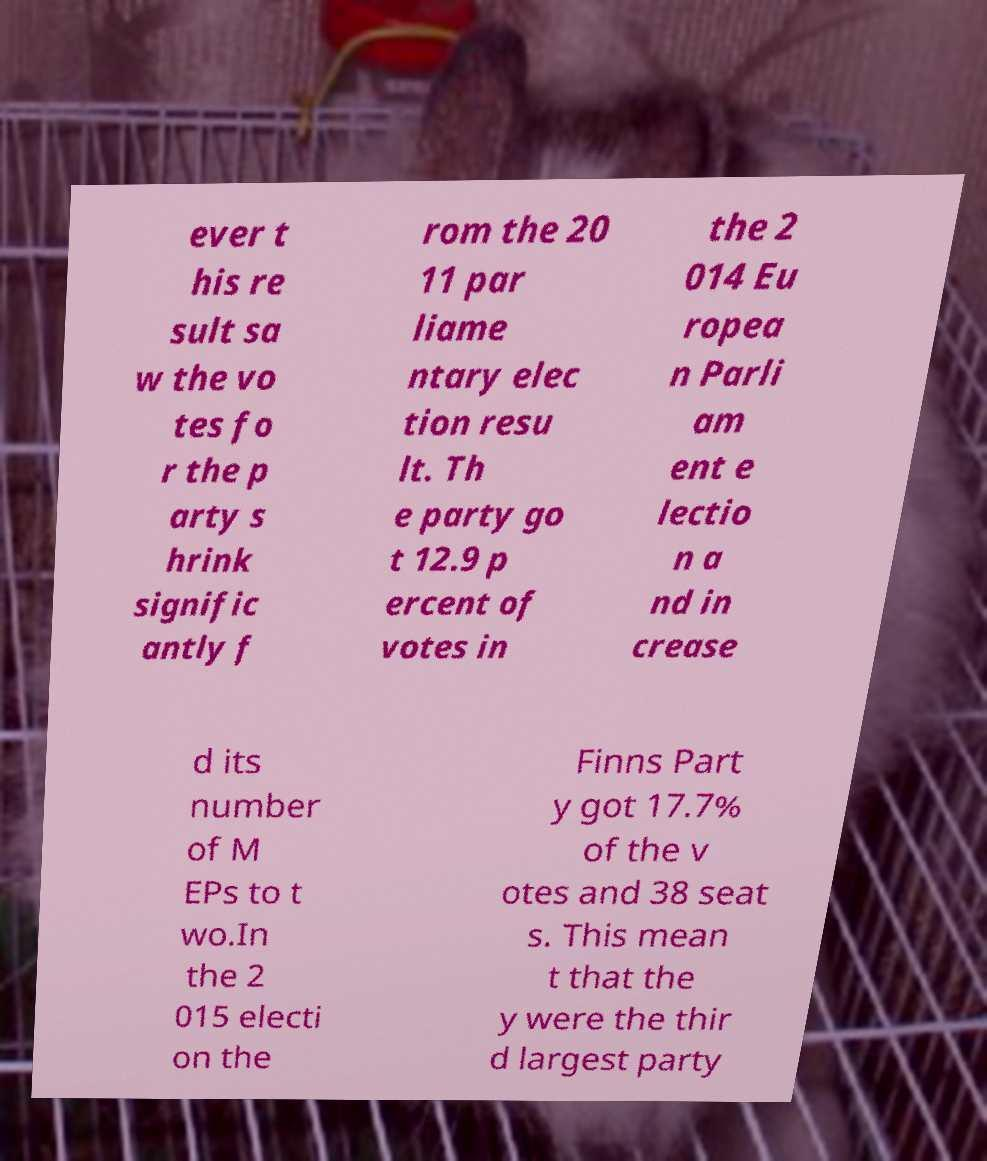There's text embedded in this image that I need extracted. Can you transcribe it verbatim? ever t his re sult sa w the vo tes fo r the p arty s hrink signific antly f rom the 20 11 par liame ntary elec tion resu lt. Th e party go t 12.9 p ercent of votes in the 2 014 Eu ropea n Parli am ent e lectio n a nd in crease d its number of M EPs to t wo.In the 2 015 electi on the Finns Part y got 17.7% of the v otes and 38 seat s. This mean t that the y were the thir d largest party 